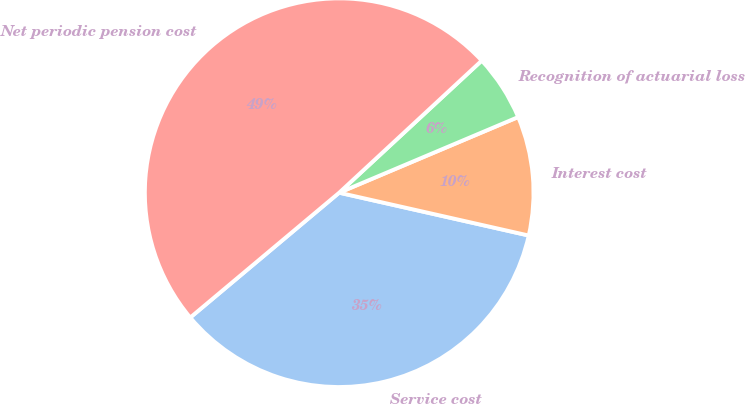<chart> <loc_0><loc_0><loc_500><loc_500><pie_chart><fcel>Service cost<fcel>Interest cost<fcel>Recognition of actuarial loss<fcel>Net periodic pension cost<nl><fcel>35.36%<fcel>9.9%<fcel>5.53%<fcel>49.21%<nl></chart> 